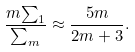<formula> <loc_0><loc_0><loc_500><loc_500>\frac { m { \sum } _ { 1 } } { { \sum } _ { m } } \approx \frac { 5 m } { 2 m + 3 } .</formula> 